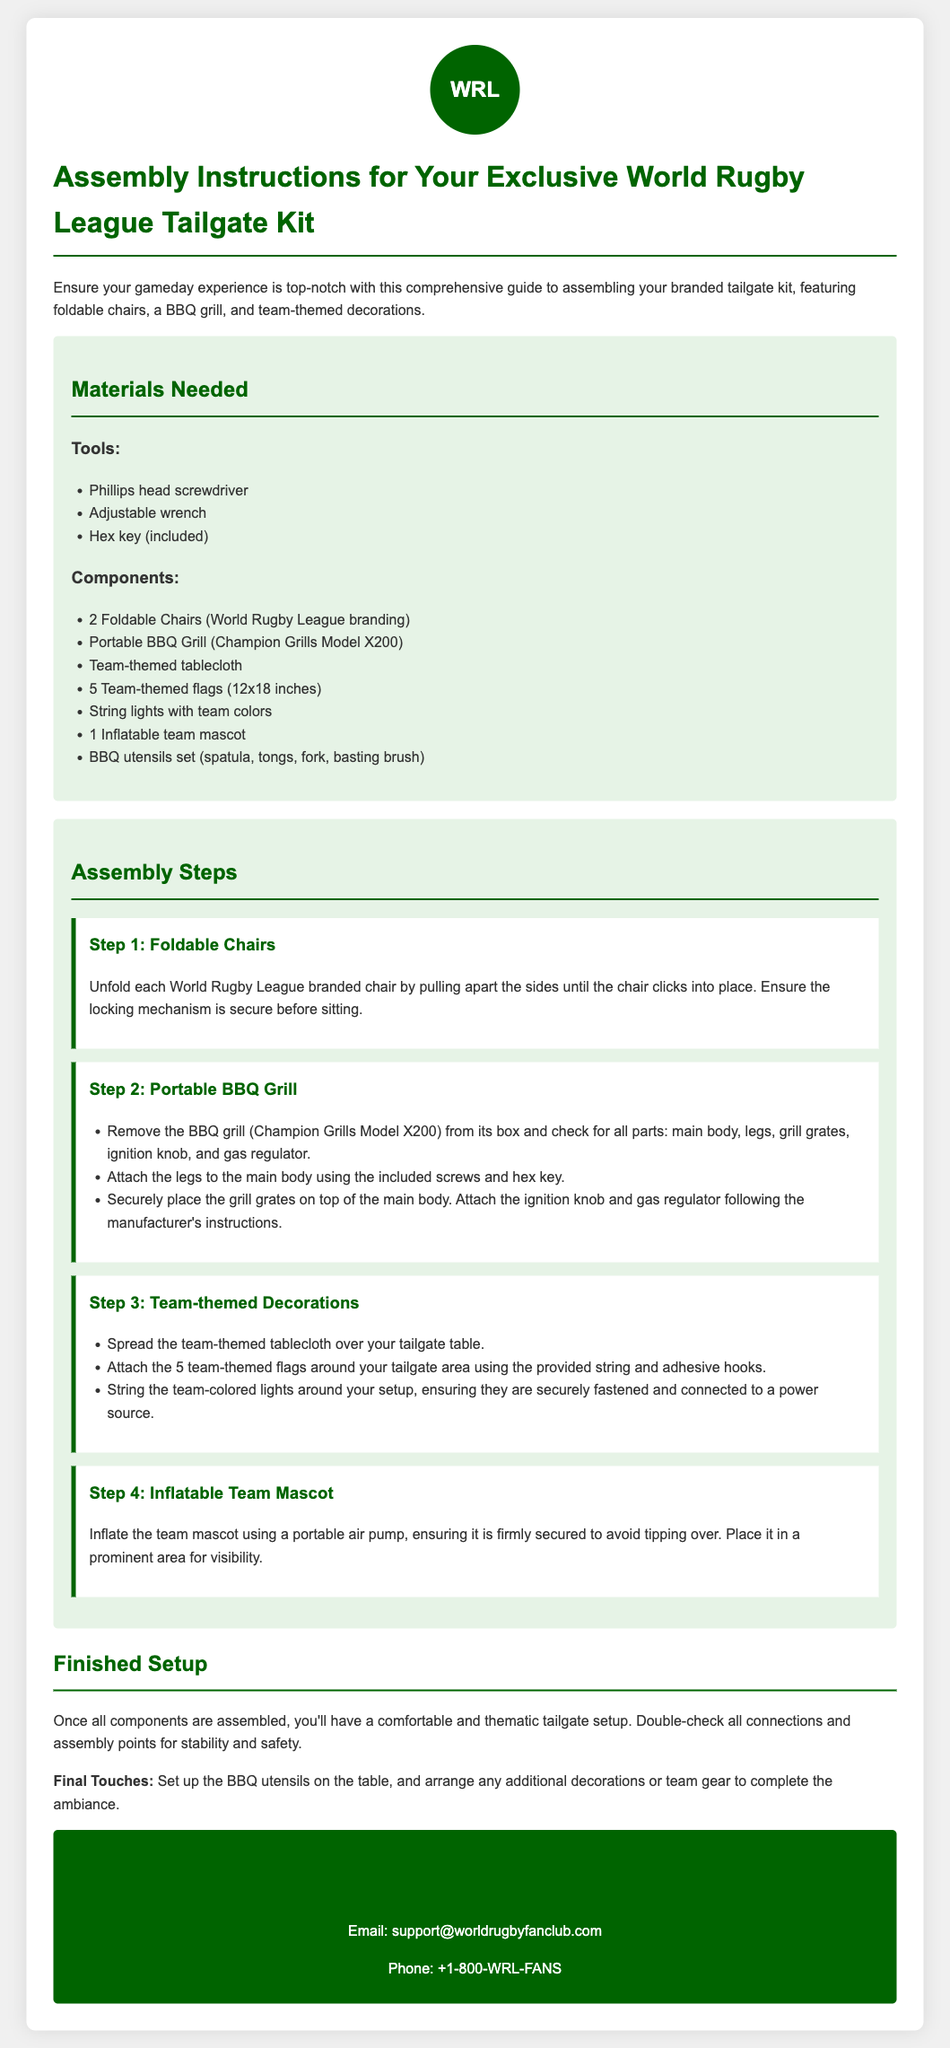what branding is on the chairs? The document specifies that the chairs have World Rugby League branding.
Answer: World Rugby League how many foldable chairs are included? The instructions state that there are 2 foldable chairs in the kit.
Answer: 2 what model is the BBQ grill? The model of the BBQ grill mentioned is Champion Grills Model X200.
Answer: Champion Grills Model X200 what tool is included for assembly? The document lists a hex key as one of the tools included for assembly.
Answer: Hex key how many team-themed flags are included? The instructions specify that there are 5 team-themed flags.
Answer: 5 what should you ensure before sitting on the chairs? The document advises to ensure the locking mechanism is secure before sitting.
Answer: locking mechanism what is the first step in the assembly instructions? According to the document, the first step is to unfold each World Rugby League branded chair.
Answer: Unfold each chair what should be done with the BBQ utensils after assembly? The instructions suggest setting up the BBQ utensils on the table after assembling.
Answer: Set up on the table how should the inflatable team mascot be secured? The document states that the mascot should be firmly secured to avoid tipping over.
Answer: Firmly secured 